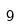Convert formula to latex. <formula><loc_0><loc_0><loc_500><loc_500>9</formula> 